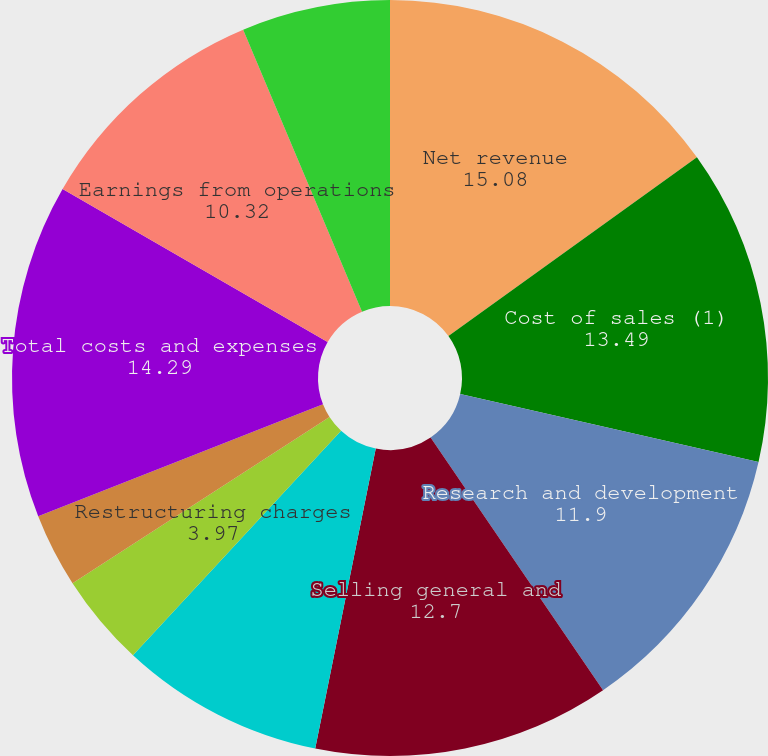Convert chart. <chart><loc_0><loc_0><loc_500><loc_500><pie_chart><fcel>Net revenue<fcel>Cost of sales (1)<fcel>Research and development<fcel>Selling general and<fcel>Amortization of purchased<fcel>Restructuring charges<fcel>Acquisition-related charges<fcel>Total costs and expenses<fcel>Earnings from operations<fcel>Interest and other net<nl><fcel>15.08%<fcel>13.49%<fcel>11.9%<fcel>12.7%<fcel>8.73%<fcel>3.97%<fcel>3.17%<fcel>14.29%<fcel>10.32%<fcel>6.35%<nl></chart> 